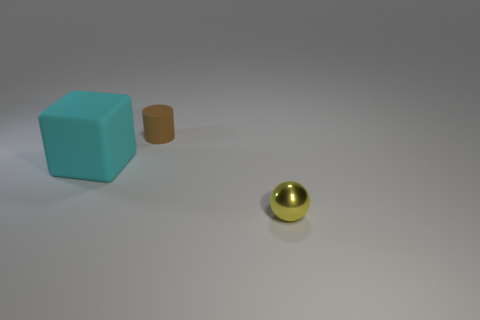Add 3 yellow cylinders. How many objects exist? 6 Subtract all cylinders. How many objects are left? 2 Subtract all yellow cubes. Subtract all gray cylinders. How many cubes are left? 1 Subtract all rubber cylinders. Subtract all cyan objects. How many objects are left? 1 Add 3 tiny yellow things. How many tiny yellow things are left? 4 Add 2 tiny purple metal things. How many tiny purple metal things exist? 2 Subtract 0 blue spheres. How many objects are left? 3 